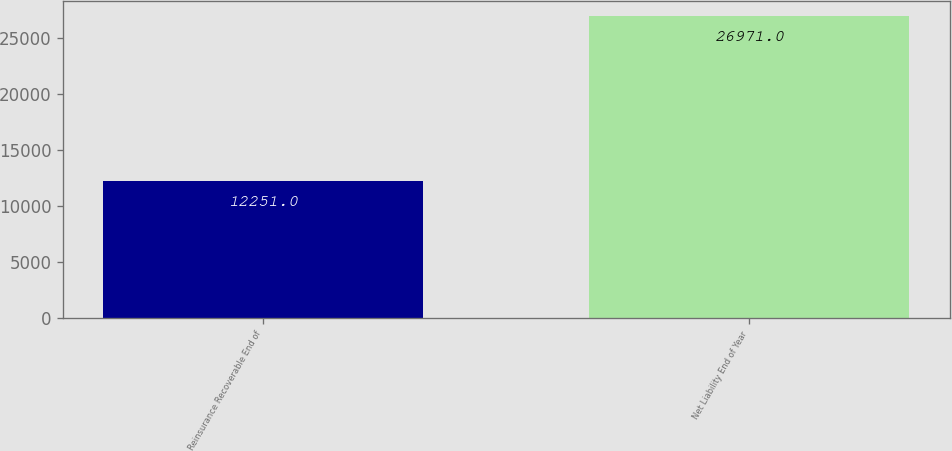Convert chart. <chart><loc_0><loc_0><loc_500><loc_500><bar_chart><fcel>Reinsurance Recoverable End of<fcel>Net Liability End of Year<nl><fcel>12251<fcel>26971<nl></chart> 